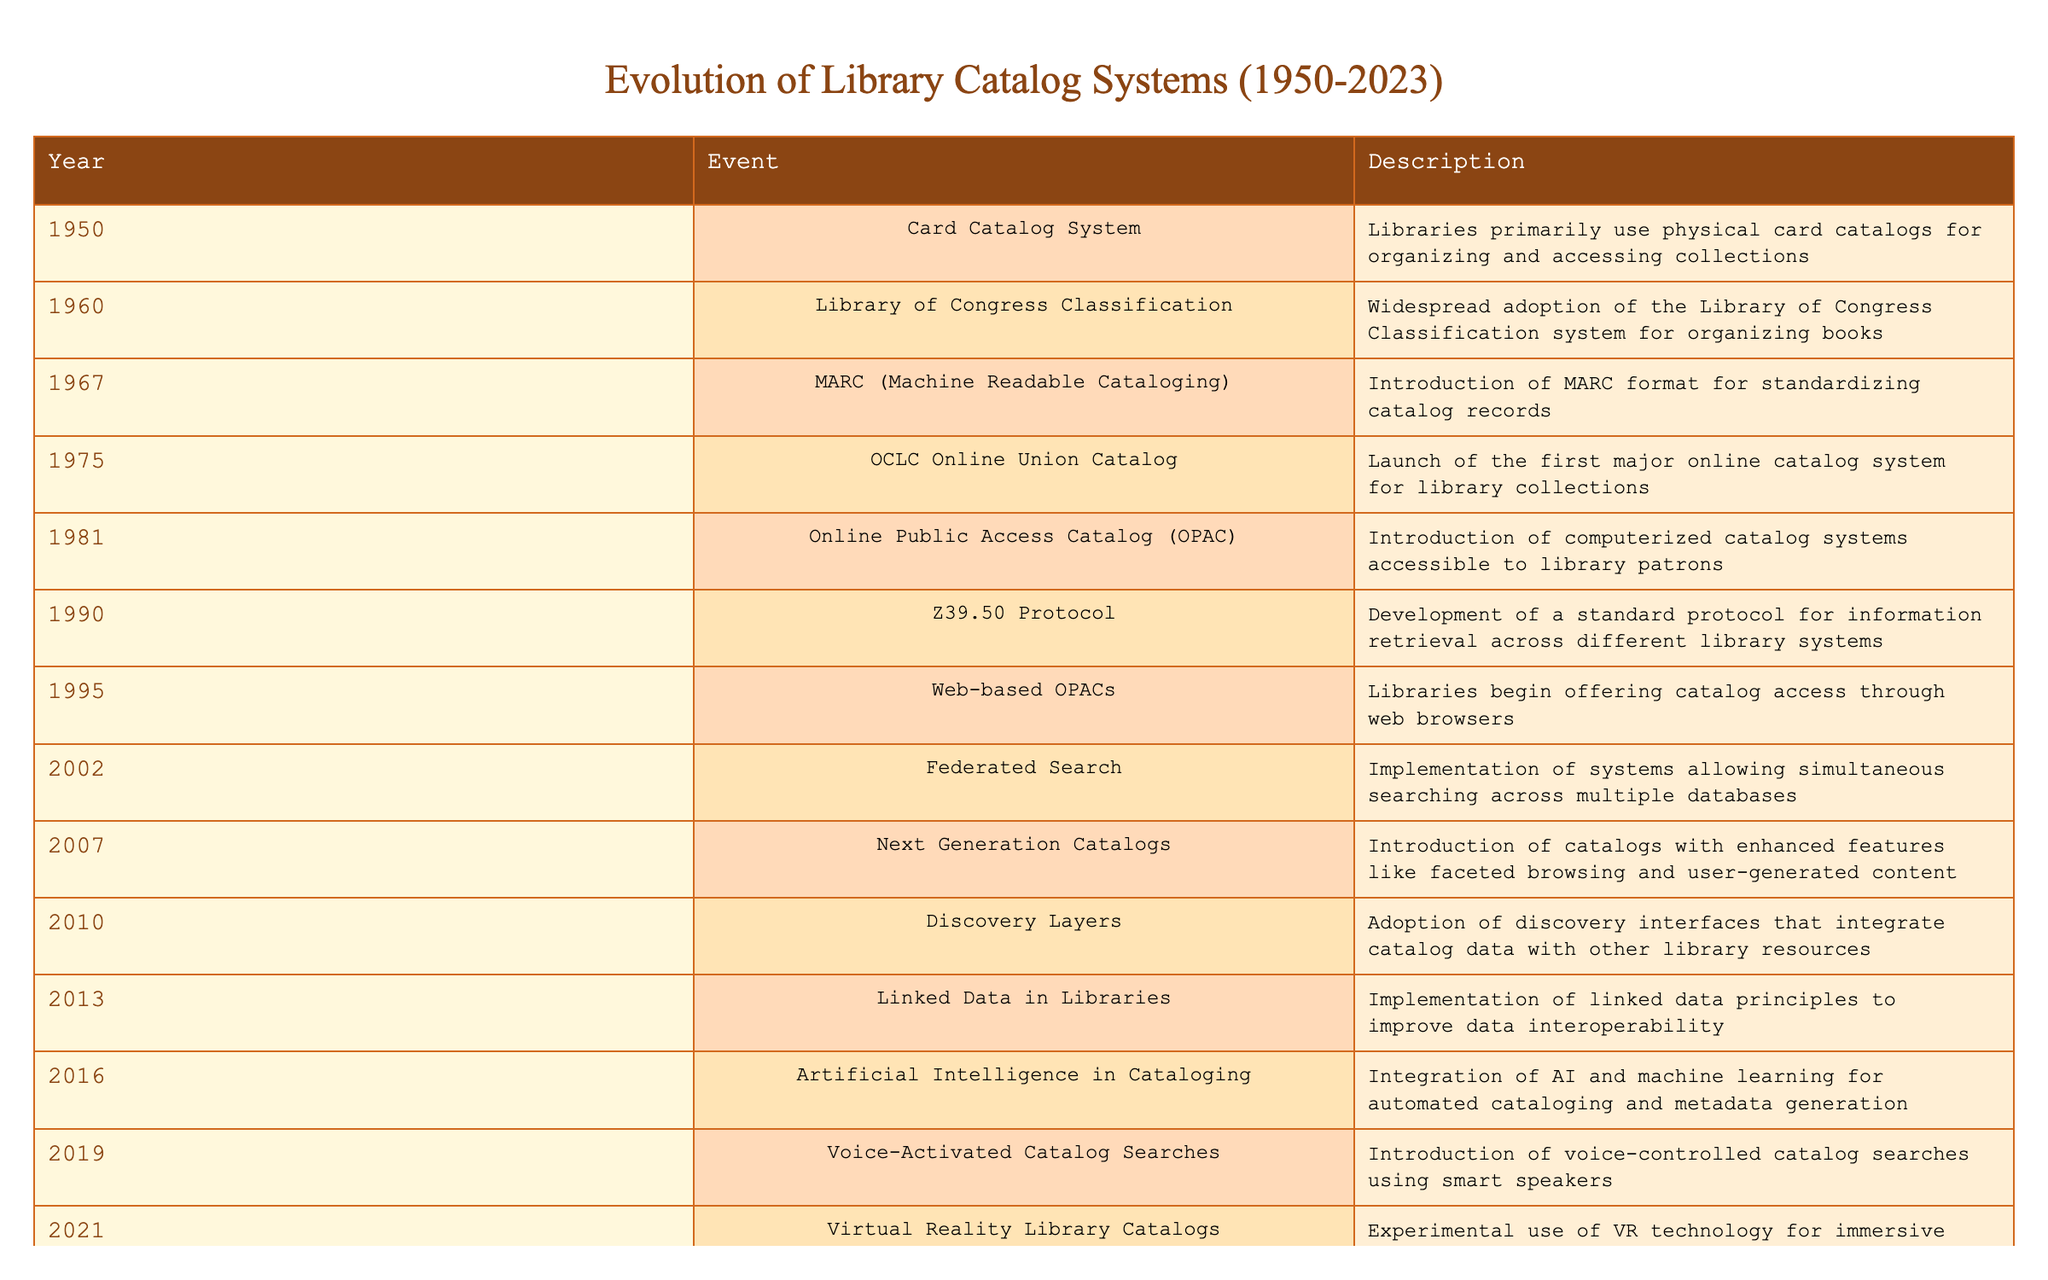What year was the introduction of the MARC format? According to the table, the MARC (Machine Readable Cataloging) format was introduced in 1967.
Answer: 1967 Which event marks the transition from physical to computerized catalog systems? The introduction of the Online Public Access Catalog (OPAC) in 1981 represents the transition from physical card catalogs to computerized systems that are accessible to library patrons.
Answer: OPAC in 1981 How many years passed between the launch of the OCLC Online Union Catalog and the introduction of web-based OPACs? The OCLC Online Union Catalog was launched in 1975, and web-based OPACs started in 1995. Thus, 1995 - 1975 = 20 years passed between these events.
Answer: 20 years Did the evolution of library catalog systems include the use of artificial intelligence? Yes, the table states that artificial intelligence in cataloging was integrated in 2016, pointing to the significant advancements in technology applied to library systems.
Answer: Yes What advancements were made in library catalog systems from the year 2007 to 2021? Between 2007 and 2021, the advancements included the introduction of next-generation catalogs in 2007, discovery layers in 2010, voice-activated catalog searches in 2019, and virtual reality library catalogs in 2021. This indicates a strong trend towards user interactivity and enhanced access.
Answer: Next-generation catalogs, discovery layers, voice-activated catalogs, virtual reality catalogs What is the average number of years between events listed in the table? There are 12 events from 1950 to 2023, covering a period of 73 years. To get the average, divide the total number of years by the number of events minus one: 73/(12-1) = approximately 6.64. Hence, the average number of years between events is a little over 6.
Answer: Approximately 6.64 years Which cataloging event occurred immediately before the implementation of linked data principles? The event that occurred immediately before the implementation of linked data principles is the introduction of next-generation catalogs in 2007. This shows a progression toward more innovative cataloging approaches.
Answer: Next-generation catalogs in 2007 Is blockchain technology being explored for library catalog systems as of 2023? Yes, the table mentions that in 2023, there is an exploration of blockchain technology for secure and decentralized catalog management in libraries. This indicates a forward-thinking approach to data management in library systems.
Answer: Yes What are the two main features enhanced by the next-generation catalogs introduced in 2007? The table states that next-generation catalogs introduced enhanced features, specifically faceted browsing and user-generated content. These features improve how users interact with catalog data.
Answer: Faceted browsing and user-generated content 